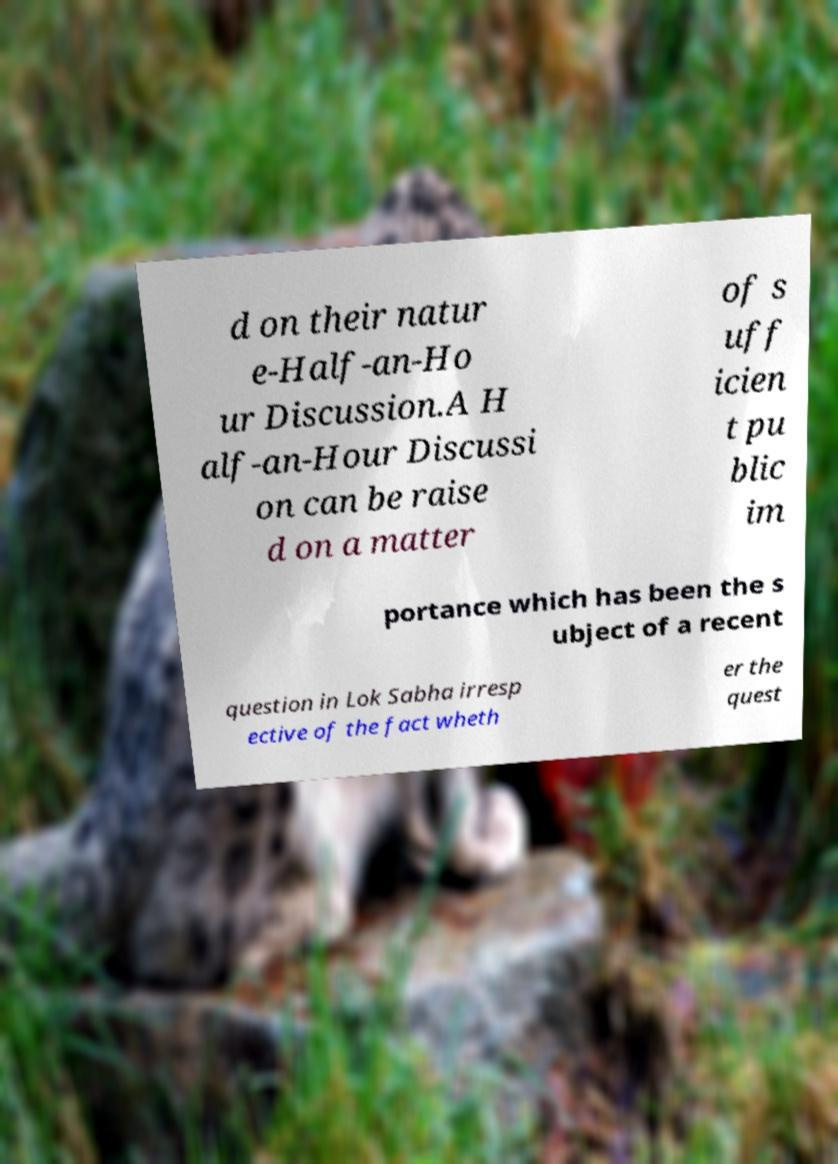Can you accurately transcribe the text from the provided image for me? d on their natur e-Half-an-Ho ur Discussion.A H alf-an-Hour Discussi on can be raise d on a matter of s uff icien t pu blic im portance which has been the s ubject of a recent question in Lok Sabha irresp ective of the fact wheth er the quest 